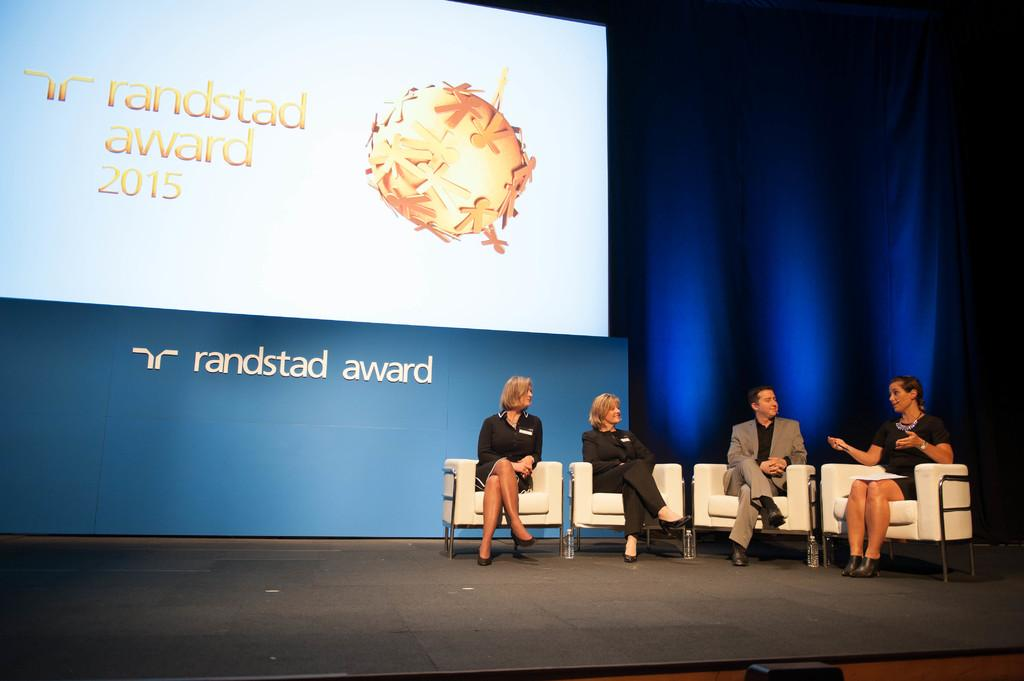What are the people on the stage doing? The people sitting on chairs on the stage are likely performing or presenting something. What can be seen behind the people on the stage? In the background, there is a screen, a poster, and a curtain. Can you describe the curtain in the background? The curtain in the background is likely a stage curtain, possibly used to separate different scenes or performances. What advice does the poster in the background give to the audience? There is no indication in the image that the poster contains any advice or message for the audience. 